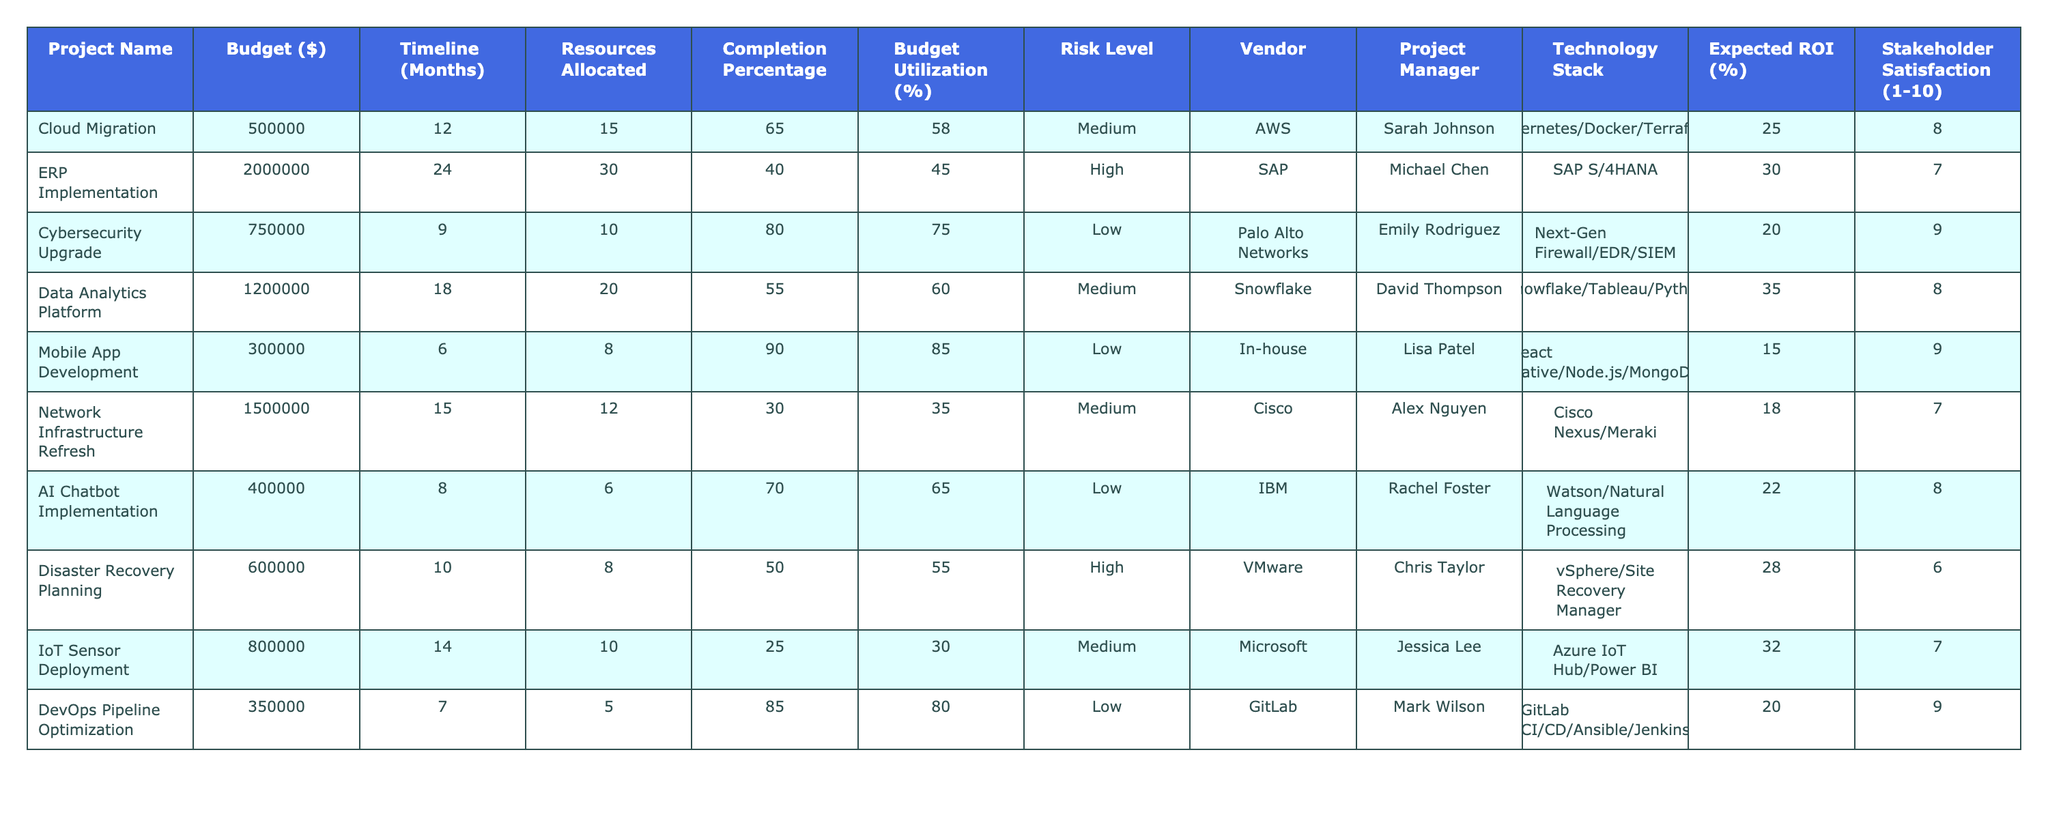What is the budget for the Cybersecurity Upgrade project? The table shows the budget column, where the value for the Cybersecurity Upgrade project is listed under the corresponding project name. The budget is $750,000.
Answer: $750,000 Which project has the highest completion percentage? Looking at the completion percentage column, we find the percentages for all projects and identify the maximum value. The Mobile App Development project has the highest completion percentage at 90%.
Answer: 90% What is the average budget for all projects listed? To find the average budget, we sum the budgets of all projects: (500,000 + 2,000,000 + 750,000 + 1,200,000 + 300,000 + 1,500,000 + 400,000 + 600,000 + 800,000 + 350,000) = 8,150,000. Dividing by the total number of projects (10) gives us an average budget of $815,000.
Answer: $815,000 Is the expected ROI for the Cloud Migration project more than the average expected ROI of all projects? First, we need to calculate the average ROI. The expected ROI values are 25, 30, 20, 35, 15, 18, 22, 28, 32, and 20. Summing these yields 300, and dividing by 10 gives an average of 30%. Since the Cloud Migration project has an ROI of 25%, it is less than the average.
Answer: No What is the total resource allocation across all projects? We examine the resources allocated for each project, sum them up: (15 + 30 + 10 + 20 + 8 + 12 + 6 + 8 + 10 + 5) =  62. This gives us a total resource allocation of 62.
Answer: 62 Which project has the lowest risk level, and what is its budget? The risk level column indicates the level for each project. The lowest risk level is "Low." Checking the projects with this classification, we identify the following: Cybersecurity Upgrade, Mobile App Development, AI Chatbot Implementation, and DevOps Pipeline Optimization. Among these, the one with the lowest budget is the Mobile App Development project, which has a budget of $300,000.
Answer: $300,000 Are there any projects that are implemented by in-house resources? We look in the Vendor column to see if any project indicates "In-house." The Mobile App Development project is the only one that fits this description. Thus, there is one project implemented in-house.
Answer: Yes What is the risk level of the project with the highest budget? We identify the project with the highest budget from the budget column. The ERP Implementation has the highest budget at $2,000,000, and its risk level is classified as "High."
Answer: High What is the percentage of budget utilization for the Data Analytics Platform? Looking in the budget utilization column, we find that the Data Analytics Platform project has a utilization percentage of 60%.
Answer: 60% 